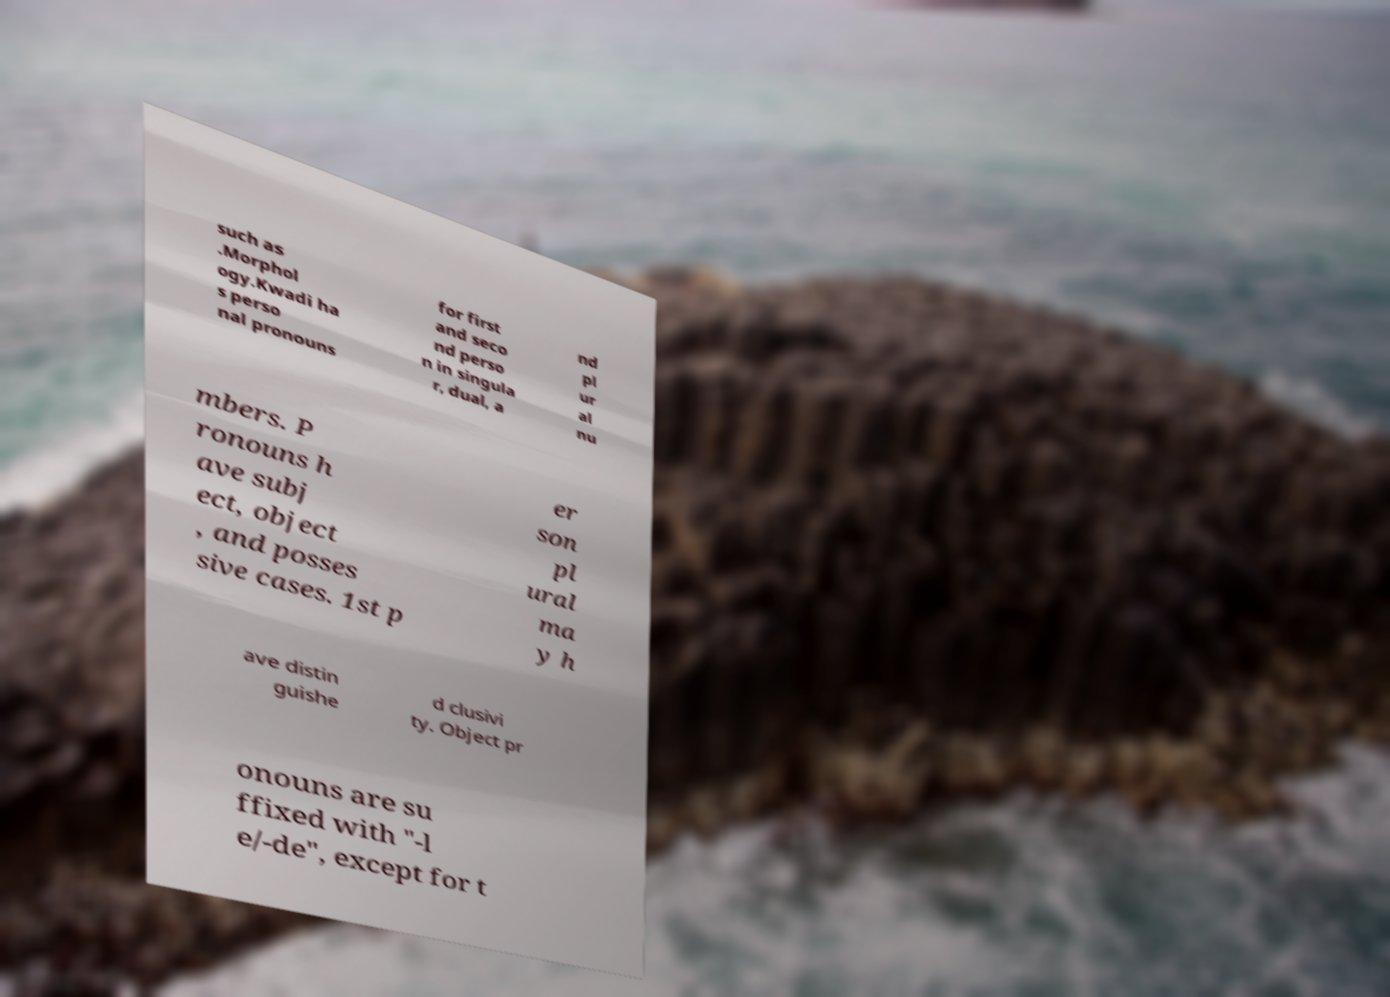Can you accurately transcribe the text from the provided image for me? such as .Morphol ogy.Kwadi ha s perso nal pronouns for first and seco nd perso n in singula r, dual, a nd pl ur al nu mbers. P ronouns h ave subj ect, object , and posses sive cases. 1st p er son pl ural ma y h ave distin guishe d clusivi ty. Object pr onouns are su ffixed with "-l e/-de", except for t 